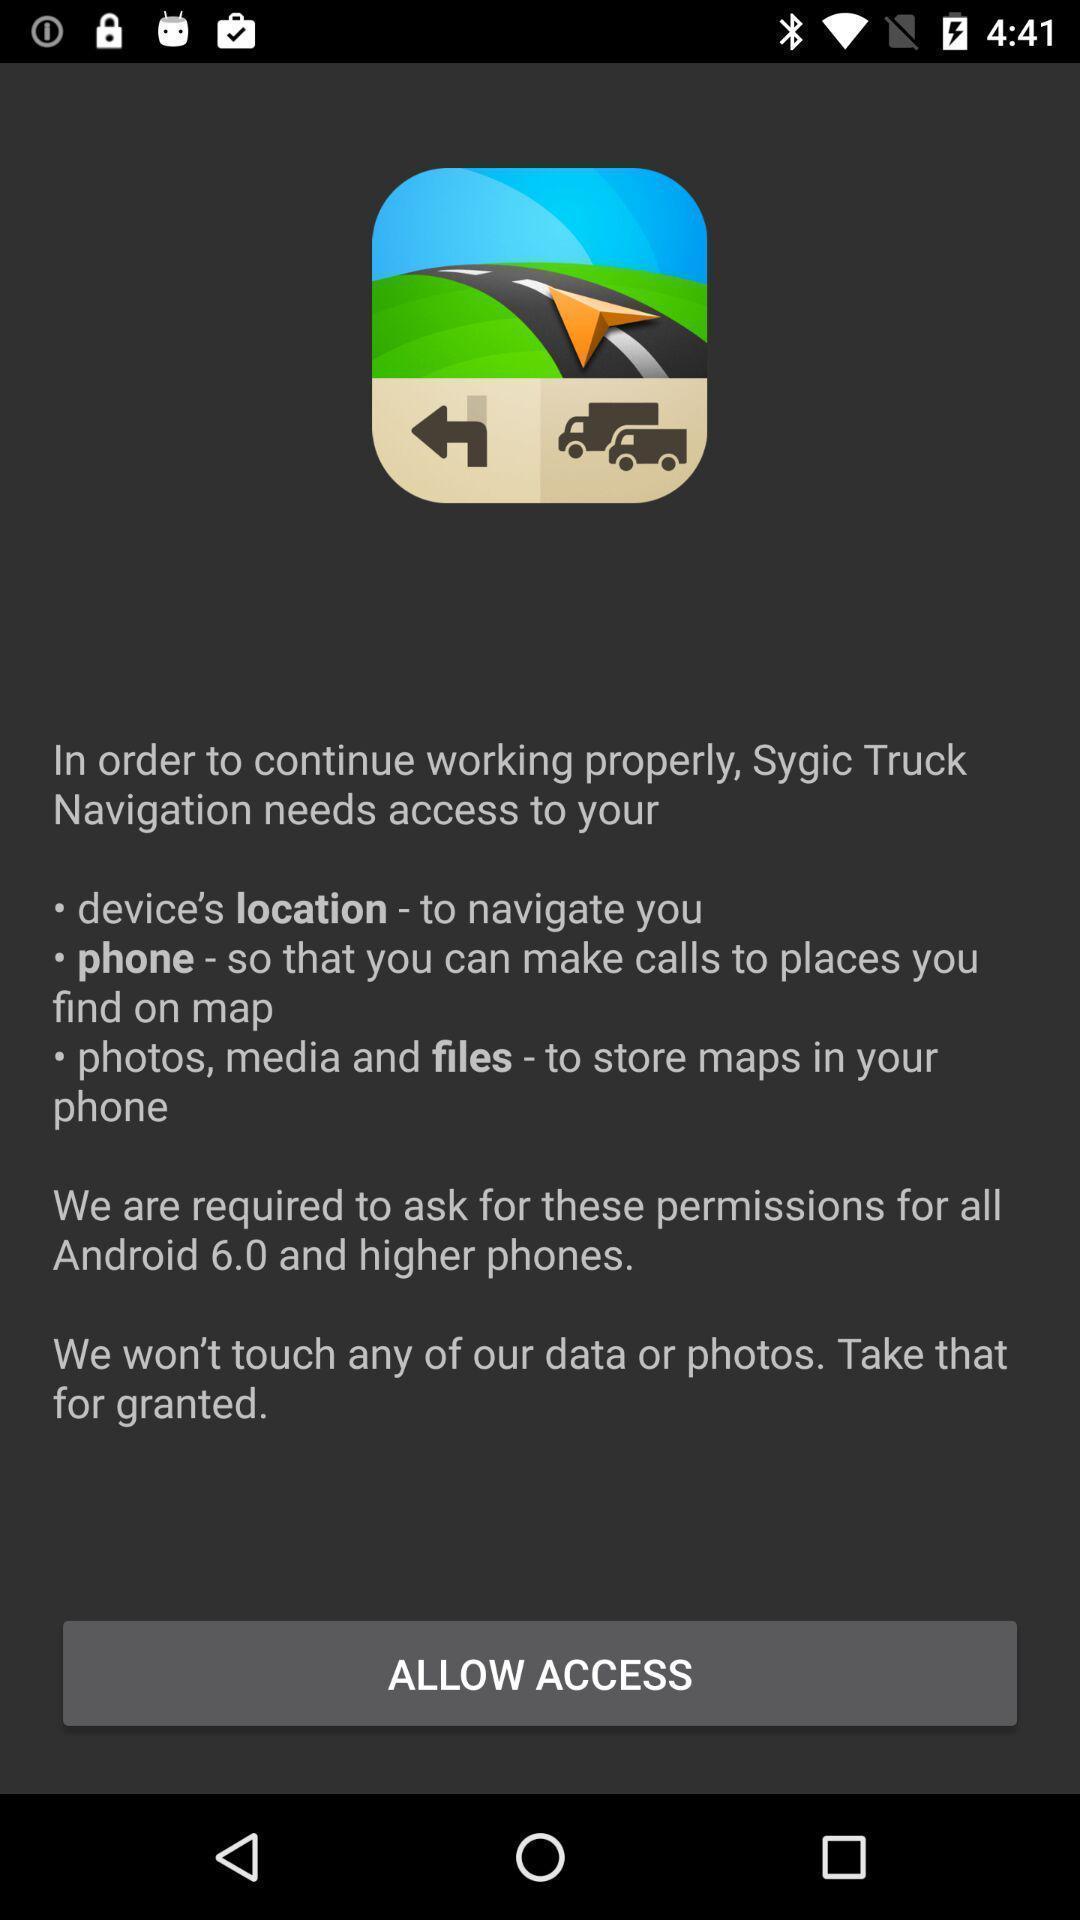Tell me about the visual elements in this screen capture. Page displaying to allow access for location. 